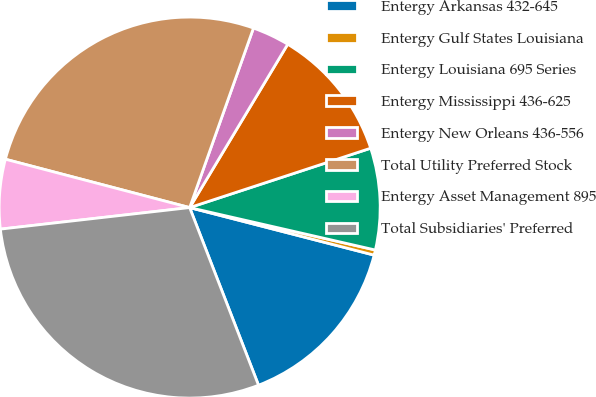Convert chart to OTSL. <chart><loc_0><loc_0><loc_500><loc_500><pie_chart><fcel>Entergy Arkansas 432-645<fcel>Entergy Gulf States Louisiana<fcel>Entergy Louisiana 695 Series<fcel>Entergy Mississippi 436-625<fcel>Entergy New Orleans 436-556<fcel>Total Utility Preferred Stock<fcel>Entergy Asset Management 895<fcel>Total Subsidiaries' Preferred<nl><fcel>15.1%<fcel>0.44%<fcel>8.62%<fcel>11.35%<fcel>3.17%<fcel>26.35%<fcel>5.89%<fcel>29.08%<nl></chart> 